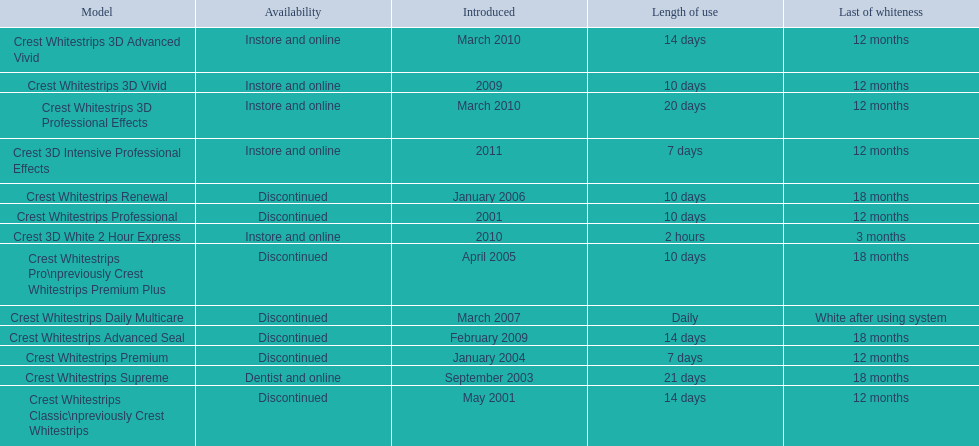What are all of the model names? Crest Whitestrips Classic\npreviously Crest Whitestrips, Crest Whitestrips Professional, Crest Whitestrips Supreme, Crest Whitestrips Premium, Crest Whitestrips Pro\npreviously Crest Whitestrips Premium Plus, Crest Whitestrips Renewal, Crest Whitestrips Daily Multicare, Crest Whitestrips Advanced Seal, Crest Whitestrips 3D Vivid, Crest Whitestrips 3D Advanced Vivid, Crest Whitestrips 3D Professional Effects, Crest 3D White 2 Hour Express, Crest 3D Intensive Professional Effects. When were they first introduced? May 2001, 2001, September 2003, January 2004, April 2005, January 2006, March 2007, February 2009, 2009, March 2010, March 2010, 2010, 2011. Along with crest whitestrips 3d advanced vivid, which other model was introduced in march 2010? Crest Whitestrips 3D Professional Effects. 